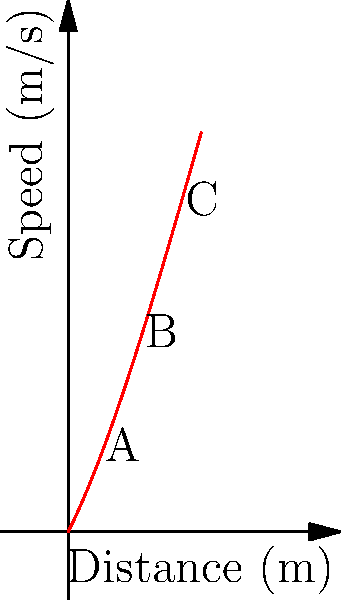Given the polynomial graph representing the relationship between a speed skater's speed and distance covered during a short track event, analyze the skater's performance. At which point (A, B, or C) does the skater achieve their maximum speed, and what does this indicate about their race strategy? To analyze the skater's performance and determine the point of maximum speed, let's follow these steps:

1. Understand the graph:
   - The x-axis represents the distance covered in meters.
   - The y-axis represents the speed in meters per second.
   - The curve is a polynomial function, showing how speed changes with distance.

2. Identify the key points:
   - Point A: Early in the race (around 2m)
   - Point B: Mid-race (around 5m)
   - Point C: Late in the race (around 8m)

3. Analyze the curve:
   - The curve starts rising steeply, indicating rapid acceleration.
   - It reaches a peak at point B.
   - After point B, the curve starts to decline, showing deceleration.

4. Determine the maximum speed:
   - The highest point on the curve represents the maximum speed.
   - This occurs at point B, in the middle of the race.

5. Interpret the race strategy:
   - The skater accelerates quickly at the start (from point A to B).
   - They reach maximum speed at the middle of the race (point B).
   - There's a slight deceleration towards the end (from B to C), possibly due to fatigue or tactical considerations.

This graph suggests a strategy where the skater aims to reach top speed by mid-race and then attempts to maintain as much of that speed as possible to the finish.
Answer: Point B; indicates rapid acceleration to mid-race peak, followed by slight deceleration. 